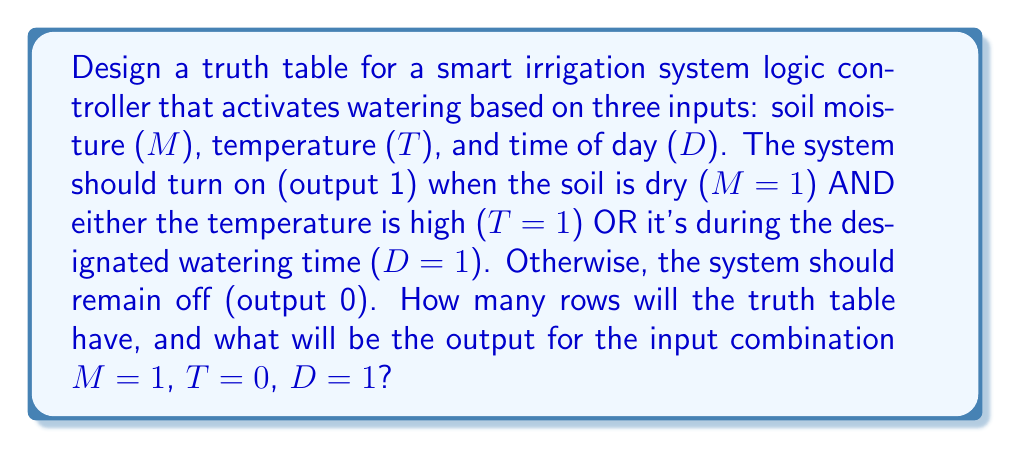Can you solve this math problem? Let's approach this step-by-step:

1. Identify the inputs and output:
   - Inputs: M (moisture), T (temperature), D (time of day)
   - Output: W (watering system)

2. Determine the number of rows in the truth table:
   - With 3 inputs, we have $2^3 = 8$ possible input combinations

3. Create the Boolean expression for the watering system:
   $W = M \cdot (T + D)$

4. Construct the truth table:

   | M | T | D | W |
   |---|---|---|---|
   | 0 | 0 | 0 | 0 |
   | 0 | 0 | 1 | 0 |
   | 0 | 1 | 0 | 0 |
   | 0 | 1 | 1 | 0 |
   | 1 | 0 | 0 | 0 |
   | 1 | 0 | 1 | 1 |
   | 1 | 1 | 0 | 1 |
   | 1 | 1 | 1 | 1 |

5. Evaluate the specific input combination (M=1, T=0, D=1):
   $W = 1 \cdot (0 + 1) = 1 \cdot 1 = 1$

Therefore, the truth table will have 8 rows, and for the input combination M=1, T=0, D=1, the output will be 1 (system on).
Answer: 8 rows; Output 1 